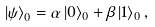<formula> <loc_0><loc_0><loc_500><loc_500>\left | { \psi } \right \rangle _ { 0 } = \alpha \left | { 0 } \right \rangle _ { 0 } + \beta \left | { 1 } \right \rangle _ { 0 } ,</formula> 